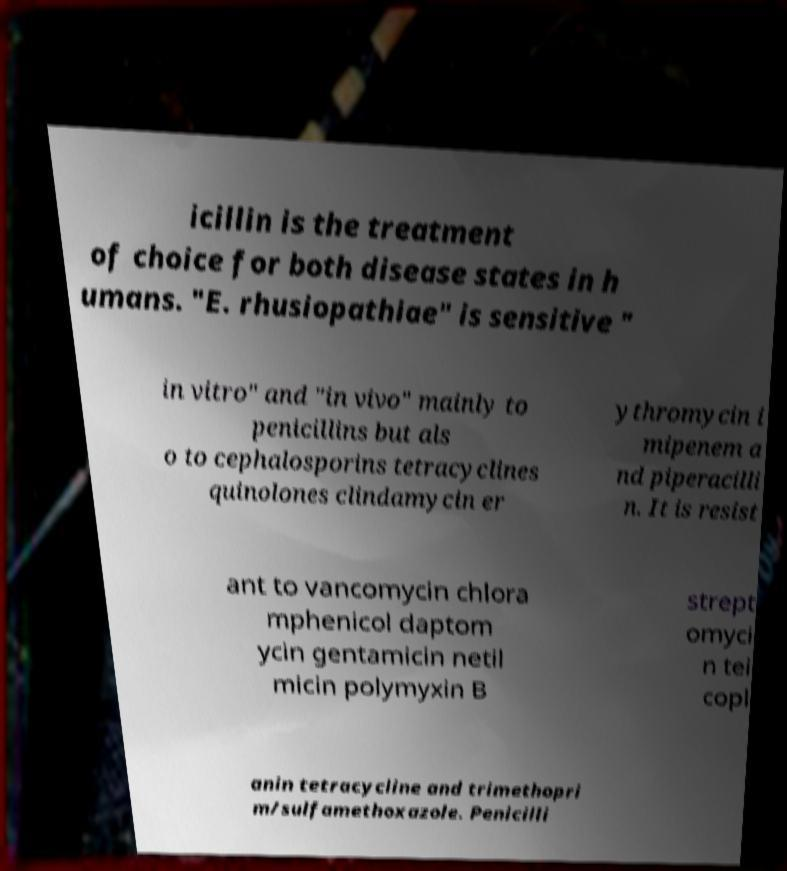Could you assist in decoding the text presented in this image and type it out clearly? icillin is the treatment of choice for both disease states in h umans. "E. rhusiopathiae" is sensitive " in vitro" and "in vivo" mainly to penicillins but als o to cephalosporins tetracyclines quinolones clindamycin er ythromycin i mipenem a nd piperacilli n. It is resist ant to vancomycin chlora mphenicol daptom ycin gentamicin netil micin polymyxin B strept omyci n tei copl anin tetracycline and trimethopri m/sulfamethoxazole. Penicilli 